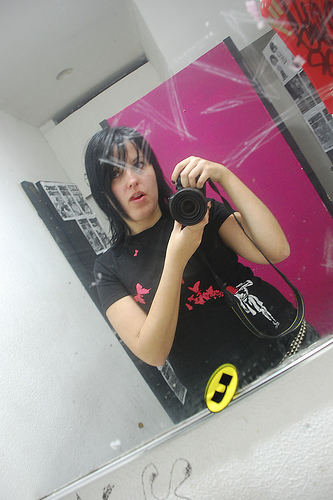<image>
Can you confirm if the girl is on the mirror? Yes. Looking at the image, I can see the girl is positioned on top of the mirror, with the mirror providing support. Is there a scratches on the mirror? Yes. Looking at the image, I can see the scratches is positioned on top of the mirror, with the mirror providing support. 